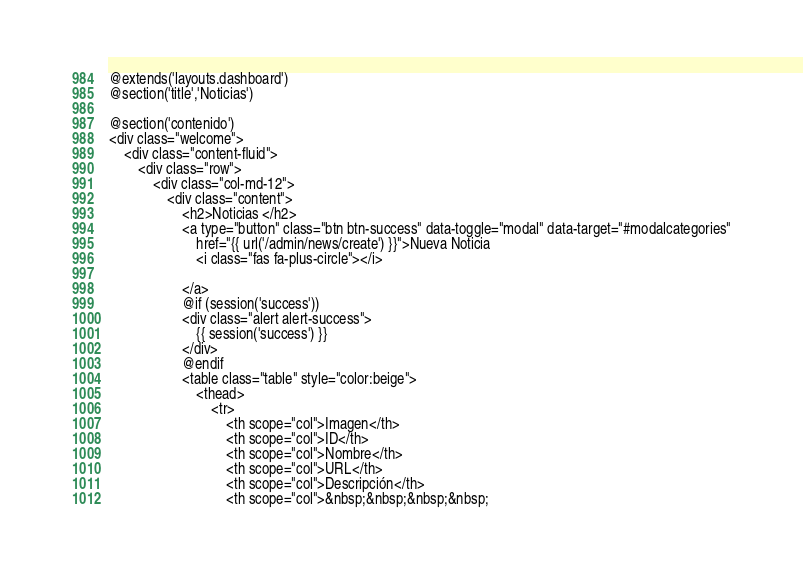<code> <loc_0><loc_0><loc_500><loc_500><_PHP_>@extends('layouts.dashboard')
@section('title','Noticias')

@section('contenido')
<div class="welcome">
    <div class="content-fluid">
        <div class="row">
            <div class="col-md-12">
                <div class="content">
                    <h2>Noticias </h2>
                    <a type="button" class="btn btn-success" data-toggle="modal" data-target="#modalcategories"
                        href="{{ url('/admin/news/create') }}">Nueva Noticia
                        <i class="fas fa-plus-circle"></i>

                    </a>
                    @if (session('success'))
                    <div class="alert alert-success">
                        {{ session('success') }}
                    </div>
                    @endif
                    <table class="table" style="color:beige">
                        <thead>
                            <tr>
                                <th scope="col">Imagen</th>
                                <th scope="col">ID</th>
                                <th scope="col">Nombre</th>
                                <th scope="col">URL</th>
                                <th scope="col">Descripción</th>
                                <th scope="col">&nbsp;&nbsp;&nbsp;&nbsp;</code> 